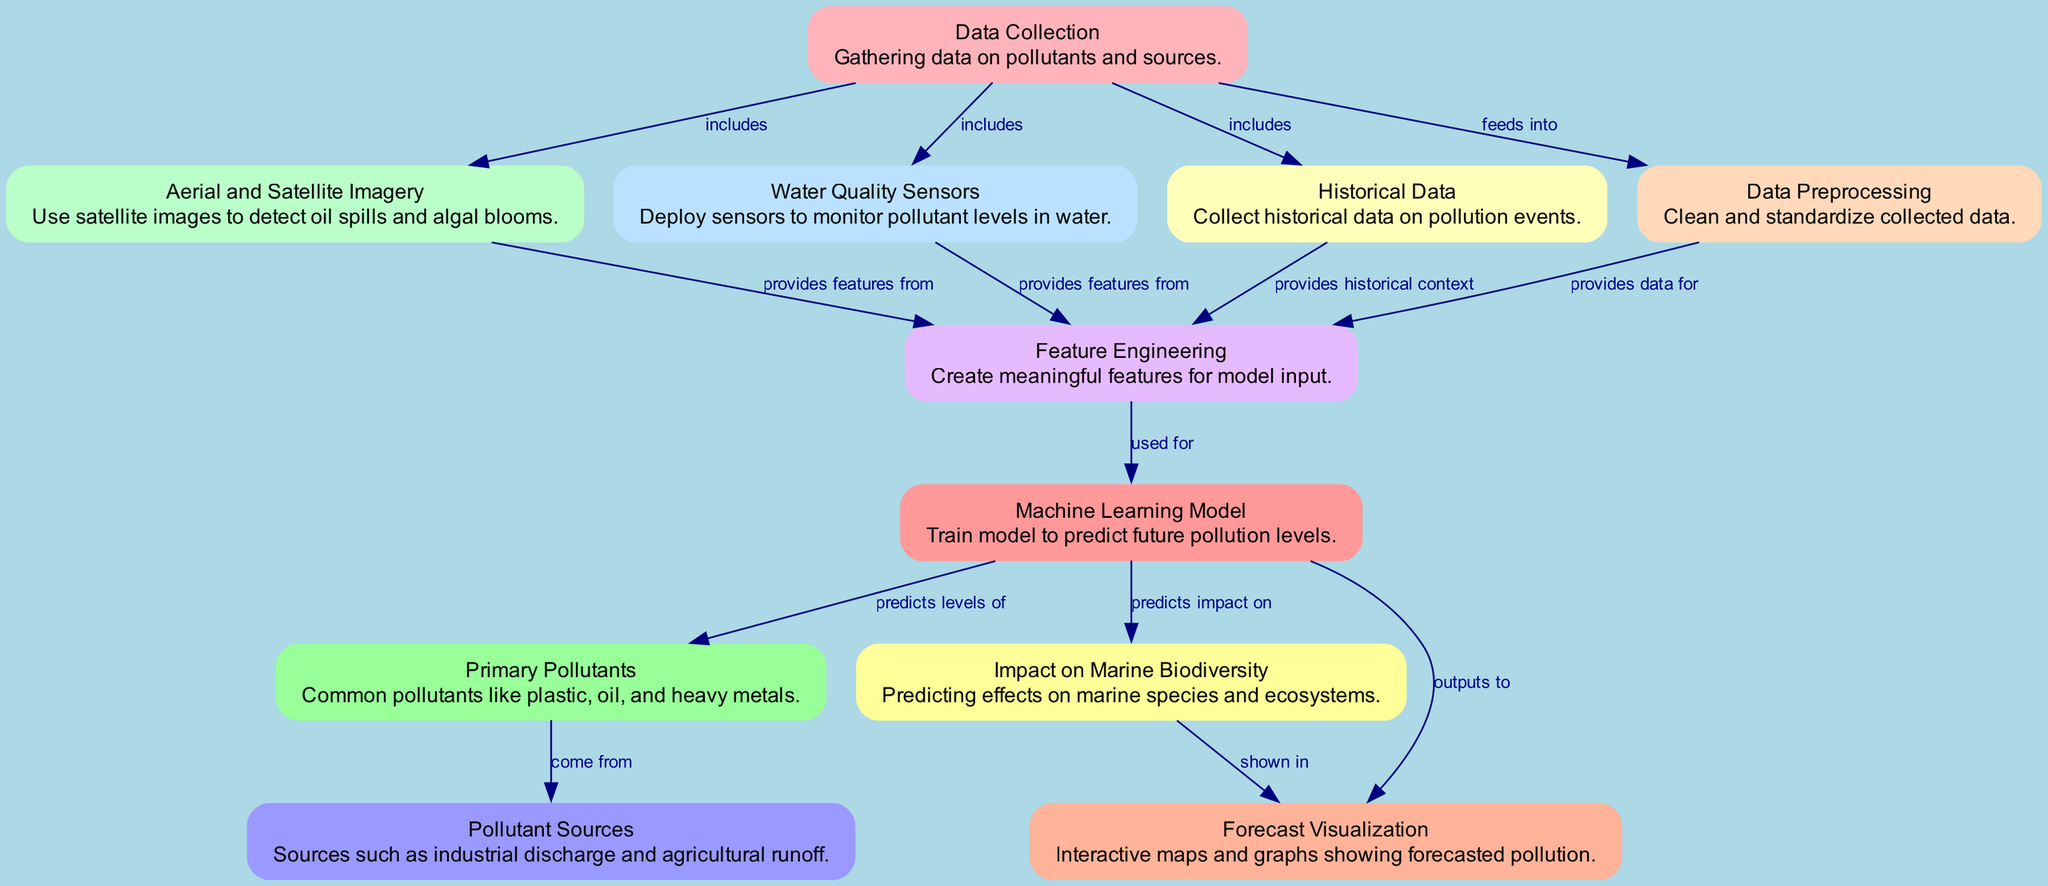What is the first node in the diagram? The diagram starts with the "Data Collection" node, which gathers information on pollutants and their sources.
Answer: Data Collection How many edges are there in the diagram? By counting the connections between nodes, there are a total of 12 edges in the diagram.
Answer: 12 What type of data do water quality sensors monitor? The "Water Quality Sensors" node monitors pollutant levels in water, as indicated in its description.
Answer: Pollutant levels in water Which node directly feeds into the "Data Preprocessing" node? The "Data Collection" node is the only node that feeds into the "Data Preprocessing" node, as shown by the directed edge in the diagram.
Answer: Data Collection What does the "Machine Learning Model" predict? According to the diagram, the "Machine Learning Model" predicts both pollution levels and the impact on marine biodiversity.
Answer: Pollution levels and impact on marine biodiversity How do "Aerial and Satellite Imagery" contribute to feature engineering? "Aerial and Satellite Imagery" provides features from satellite images, which are then used in feature engineering for the model.
Answer: Provides features from Which pollutants are highlighted as primary pollutants in the diagram? The node labeled "Primary Pollutants" lists common pollutants like plastic, oil, and heavy metals, specifying what kind of pollutants are of concern.
Answer: Plastic, oil, and heavy metals What type of visualization is used to display the forecasted pollution levels? The "Forecast Visualization" node in the diagram indicates that interactive maps and graphs are utilized to visualize the forecasted pollution levels.
Answer: Interactive maps and graphs What do historical data contribute to feature engineering? Historical data provides critical context that is utilized in feature engineering when creating meaningful features for model input.
Answer: Provides historical context What impact does the diagram predict on marine biodiversity? The impact on marine biodiversity is detailed in the "Impact on Marine Biodiversity" node, which predicts the effects on marine species and ecosystems.
Answer: Effects on marine species and ecosystems 